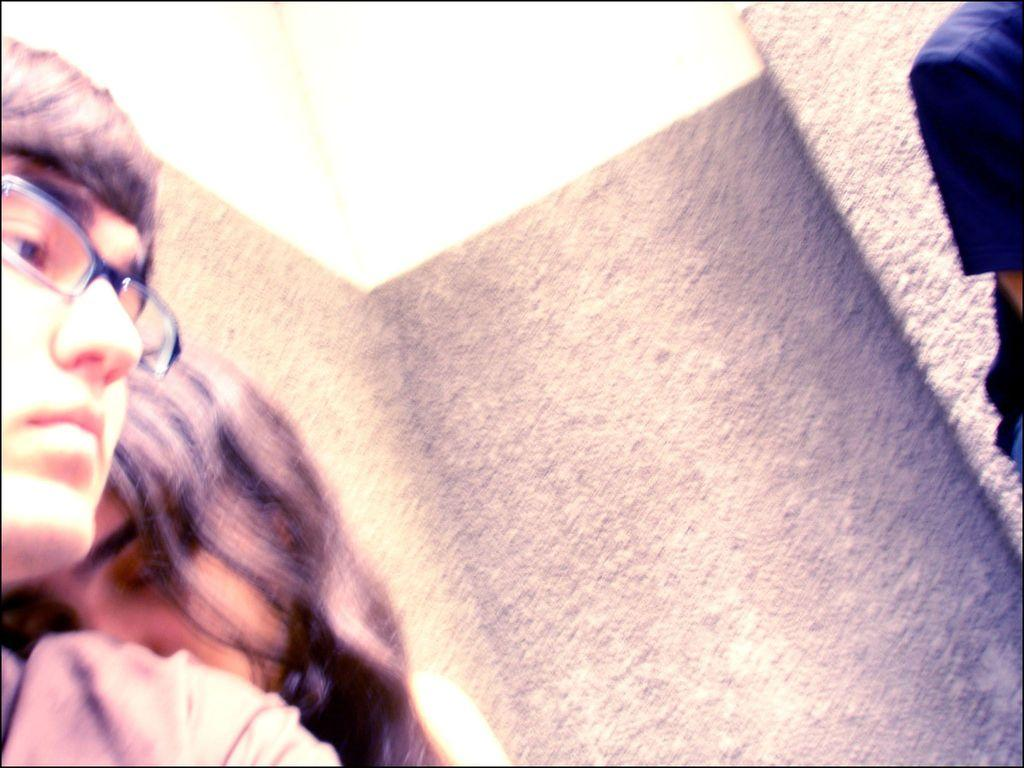How many people are on the left side of the image? There is a man and a woman on the left side of the image. Can you describe the person on the right side of the image? There is a person on the right side of the image, but their gender or appearance cannot be determined from the provided facts. What is visible in the background of the image? There is a wall in the background of the image. What type of glue is being used to cover the feast in the image? There is no feast or glue present in the image. 